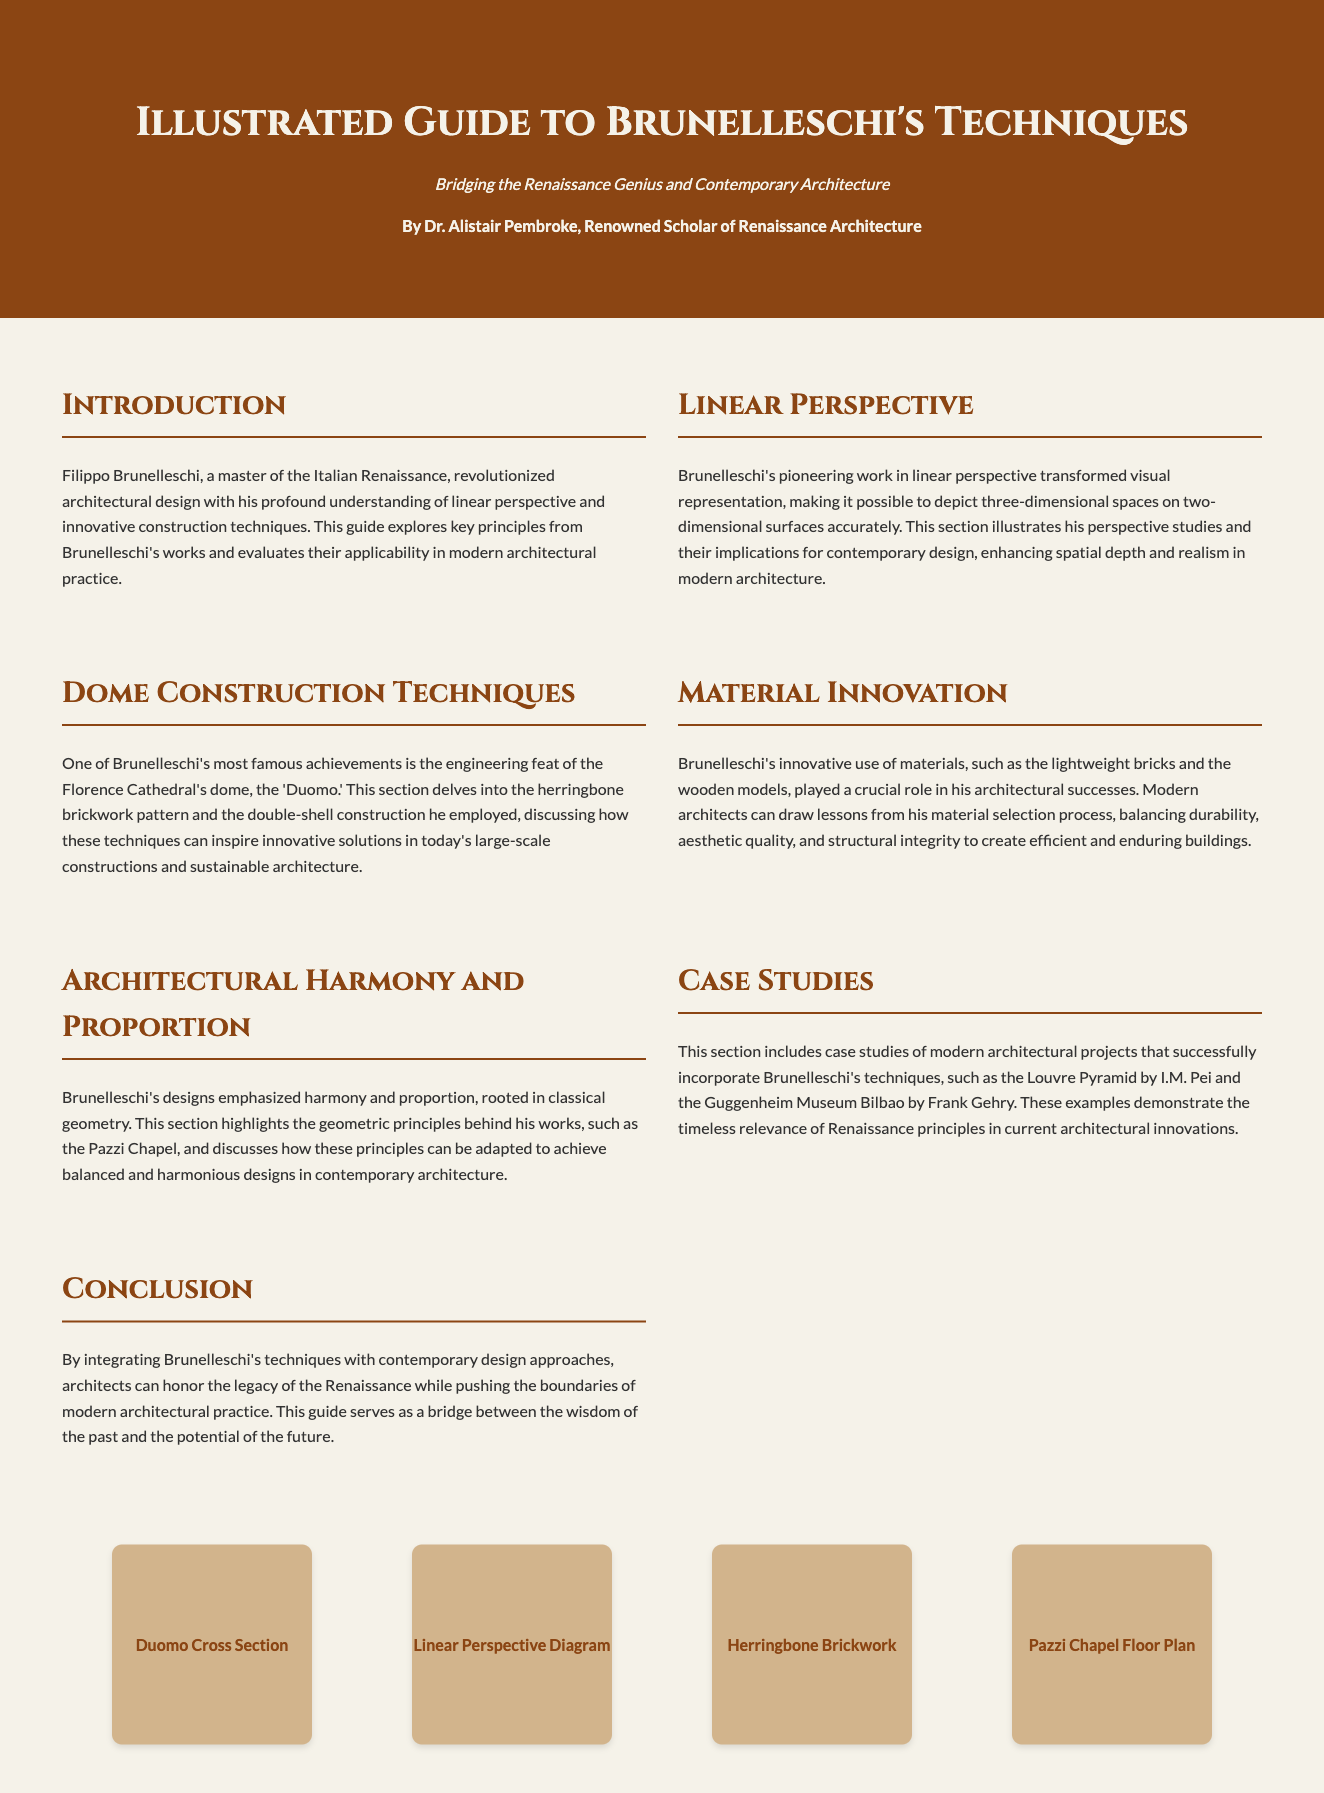What is the title of the guide? The title of the guide is prominently displayed in the header section of the document.
Answer: Illustrated Guide to Brunelleschi's Techniques Who is the author of the guide? The author's name is mentioned in the header, indicating their scholarly credentials related to the subject.
Answer: Dr. Alistair Pembroke What technique is emphasized for modern architecture from Brunelleschi's works? The document explicitly discusses key techniques from Brunelleschi's works applicable to modern architecture.
Answer: Linear Perspective Which famous dome is highlighted for its construction techniques? The text references a specific iconic structure associated with Brunelleschi's engineering methods.
Answer: Florence Cathedral's dome What architectural principle is emphasized in the designs discussed? The document highlights a fundamental aspect of Brunelleschi's architectural style regarding design quality.
Answer: Harmony and Proportion What is one example of a modern project mentioned that incorporates Brunelleschi's techniques? A specific modern architectural example is provided to illustrate the relevance of Brunelleschi's principles.
Answer: Louvre Pyramid What material innovation is discussed in Brunelleschi's techniques? The text describes a specific material innovation that Brunelleschi effectively utilized in his work.
Answer: Lightweight bricks What is the main theme of the conclusion in the guide? The conclusion summarizes the key takeaway regarding the integration of historical techniques with contemporary practices.
Answer: Integration of Brunelleschi's techniques with contemporary design approaches 